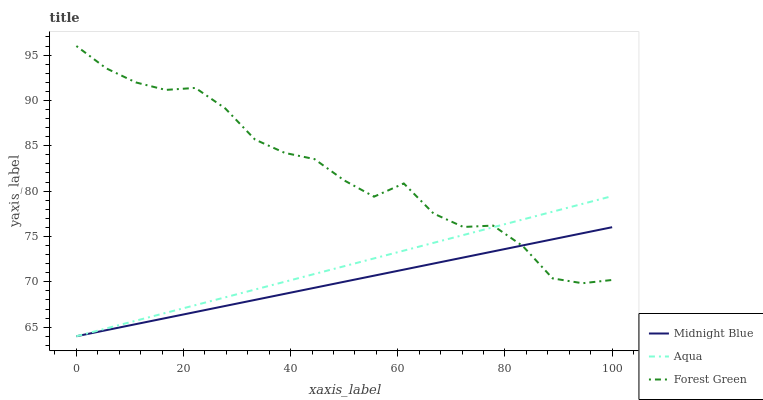Does Midnight Blue have the minimum area under the curve?
Answer yes or no. Yes. Does Forest Green have the maximum area under the curve?
Answer yes or no. Yes. Does Aqua have the minimum area under the curve?
Answer yes or no. No. Does Aqua have the maximum area under the curve?
Answer yes or no. No. Is Midnight Blue the smoothest?
Answer yes or no. Yes. Is Forest Green the roughest?
Answer yes or no. Yes. Is Aqua the smoothest?
Answer yes or no. No. Is Aqua the roughest?
Answer yes or no. No. Does Aqua have the lowest value?
Answer yes or no. Yes. Does Forest Green have the highest value?
Answer yes or no. Yes. Does Aqua have the highest value?
Answer yes or no. No. Does Midnight Blue intersect Forest Green?
Answer yes or no. Yes. Is Midnight Blue less than Forest Green?
Answer yes or no. No. Is Midnight Blue greater than Forest Green?
Answer yes or no. No. 